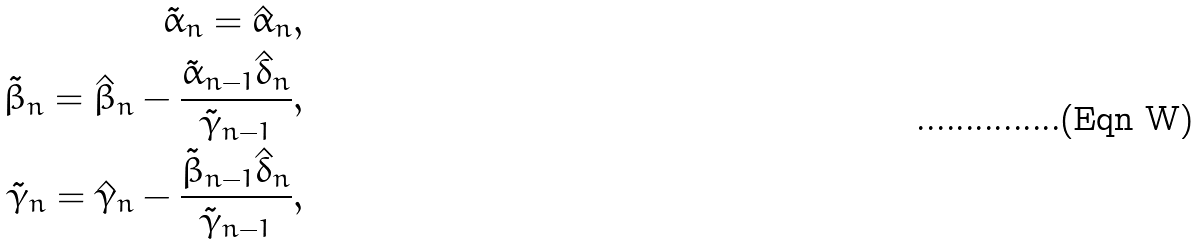Convert formula to latex. <formula><loc_0><loc_0><loc_500><loc_500>\tilde { \alpha } _ { n } = \hat { \alpha } _ { n } , \\ \tilde { \beta } _ { n } = \hat { \beta } _ { n } - \frac { \tilde { \alpha } _ { n - 1 } \hat { \delta } _ { n } } { \tilde { \gamma } _ { n - 1 } } , \\ \tilde { \gamma } _ { n } = \hat { \gamma } _ { n } - \frac { \tilde { \beta } _ { n - 1 } \hat { \delta } _ { n } } { \tilde { \gamma } _ { n - 1 } } ,</formula> 